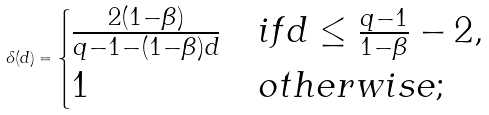<formula> <loc_0><loc_0><loc_500><loc_500>\delta ( d ) = \begin{cases} \frac { 2 ( 1 - \beta ) } { q - 1 - ( 1 - \beta ) d } & i f d \leq \frac { q - 1 } { 1 - \beta } - 2 , \\ 1 & o t h e r w i s e ; \end{cases}</formula> 